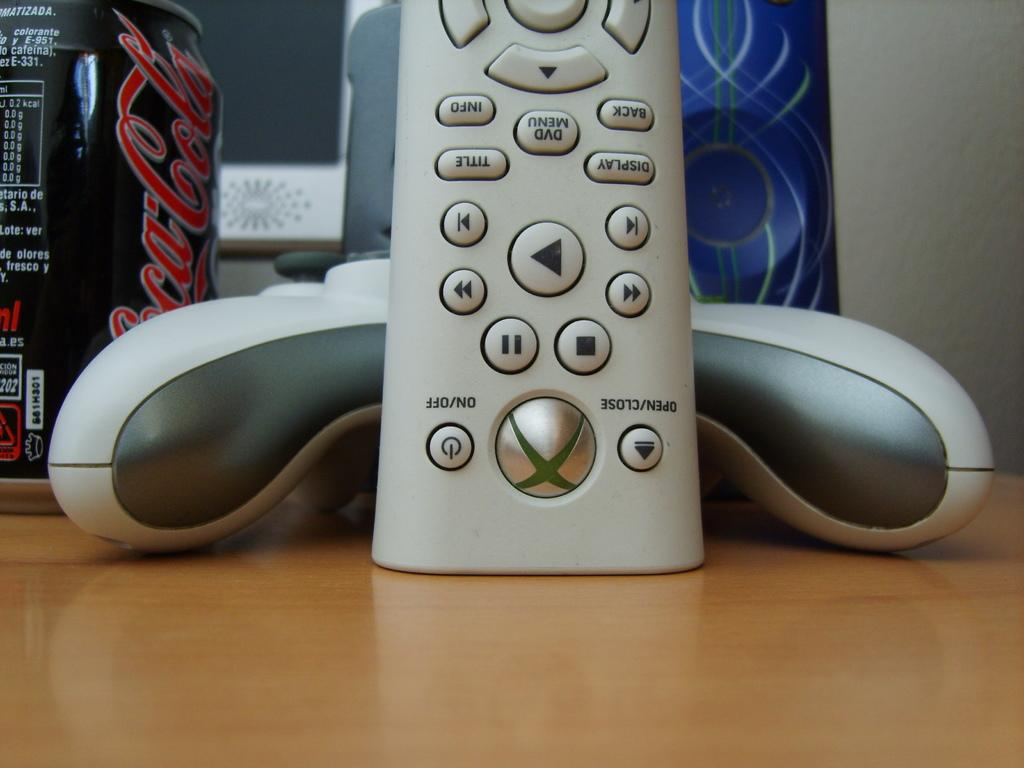<image>
Create a compact narrative representing the image presented. Coca Cola is the brand name on the side of this can. 